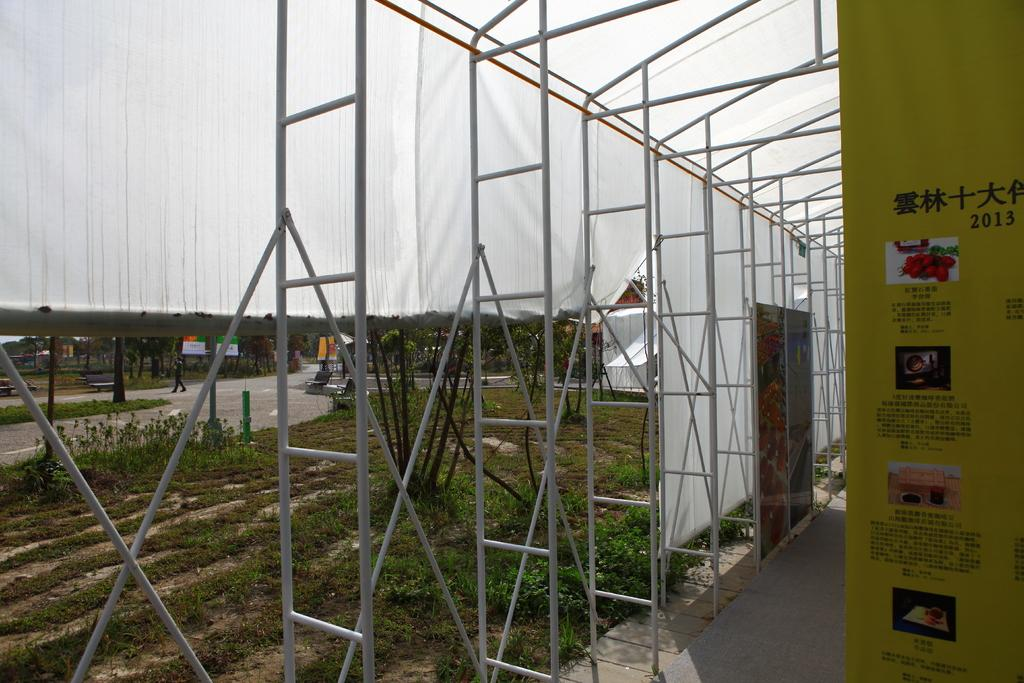What is supporting the white shed in the image? There are boards under the white shed in the image. What type of material are the pillars made of? The pillars beside the boards are made of iron. What type of vegetation can be seen in the image? There are plants in the image. What type of pathway is visible in the image? There is a road visible in the image. What type of butter is being used to grease the road in the image? There is no butter present in the image, nor is there any indication that the road is being greased. 